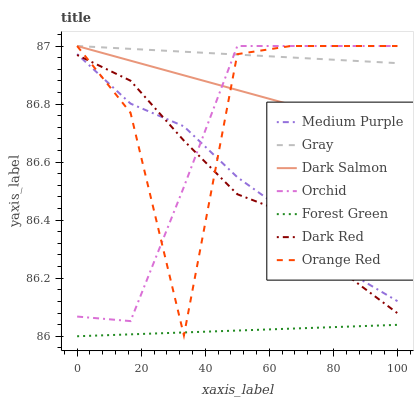Does Dark Red have the minimum area under the curve?
Answer yes or no. No. Does Dark Red have the maximum area under the curve?
Answer yes or no. No. Is Dark Red the smoothest?
Answer yes or no. No. Is Dark Red the roughest?
Answer yes or no. No. Does Dark Red have the lowest value?
Answer yes or no. No. Does Dark Red have the highest value?
Answer yes or no. No. Is Forest Green less than Medium Purple?
Answer yes or no. Yes. Is Dark Red greater than Forest Green?
Answer yes or no. Yes. Does Forest Green intersect Medium Purple?
Answer yes or no. No. 